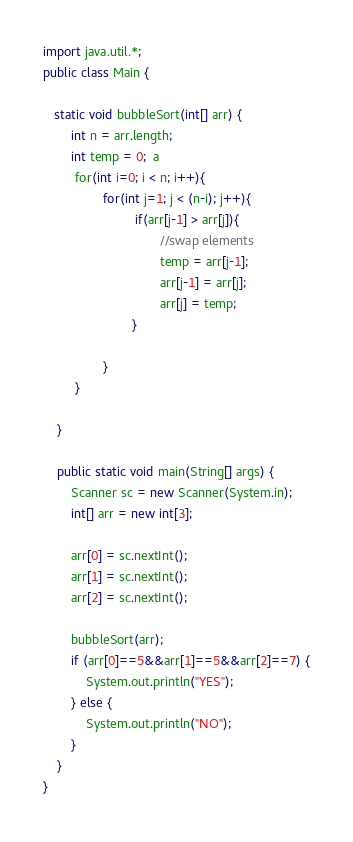Convert code to text. <code><loc_0><loc_0><loc_500><loc_500><_Java_>import java.util.*;
public class Main {
   
   static void bubbleSort(int[] arr) {  
        int n = arr.length;  
        int temp = 0;  a
         for(int i=0; i < n; i++){  
                 for(int j=1; j < (n-i); j++){  
                          if(arr[j-1] > arr[j]){  
                                 //swap elements  
                                 temp = arr[j-1];  
                                 arr[j-1] = arr[j];  
                                 arr[j] = temp;  
                         }  
                          
                 }  
         }  
  
    }  

	public static void main(String[] args) {
        Scanner sc = new Scanner(System.in);
        int[] arr = new int[3];

        arr[0] = sc.nextInt();
        arr[1] = sc.nextInt();
        arr[2] = sc.nextInt();

        bubbleSort(arr);
        if (arr[0]==5&&arr[1]==5&&arr[2]==7) {
        	System.out.println("YES");
        } else {
        	System.out.println("NO");
        }
    }
}	</code> 